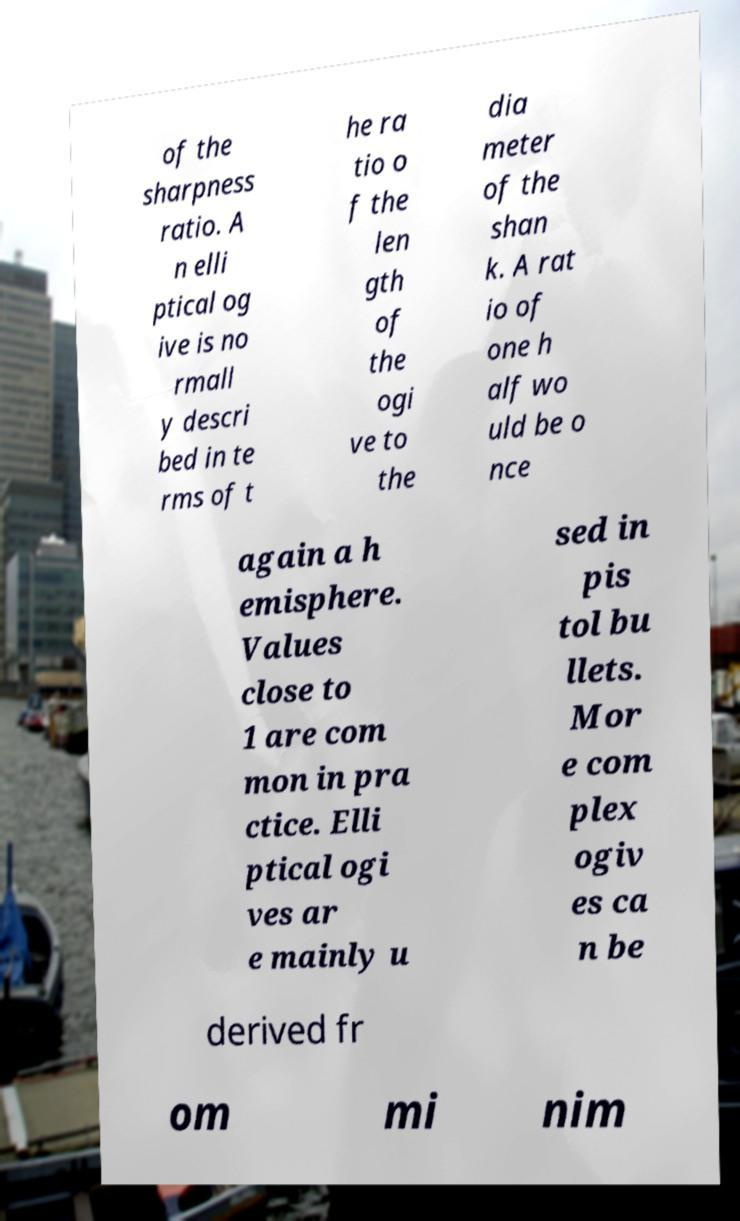Can you accurately transcribe the text from the provided image for me? of the sharpness ratio. A n elli ptical og ive is no rmall y descri bed in te rms of t he ra tio o f the len gth of the ogi ve to the dia meter of the shan k. A rat io of one h alf wo uld be o nce again a h emisphere. Values close to 1 are com mon in pra ctice. Elli ptical ogi ves ar e mainly u sed in pis tol bu llets. Mor e com plex ogiv es ca n be derived fr om mi nim 